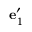Convert formula to latex. <formula><loc_0><loc_0><loc_500><loc_500>{ e } _ { 1 } ^ { \prime }</formula> 